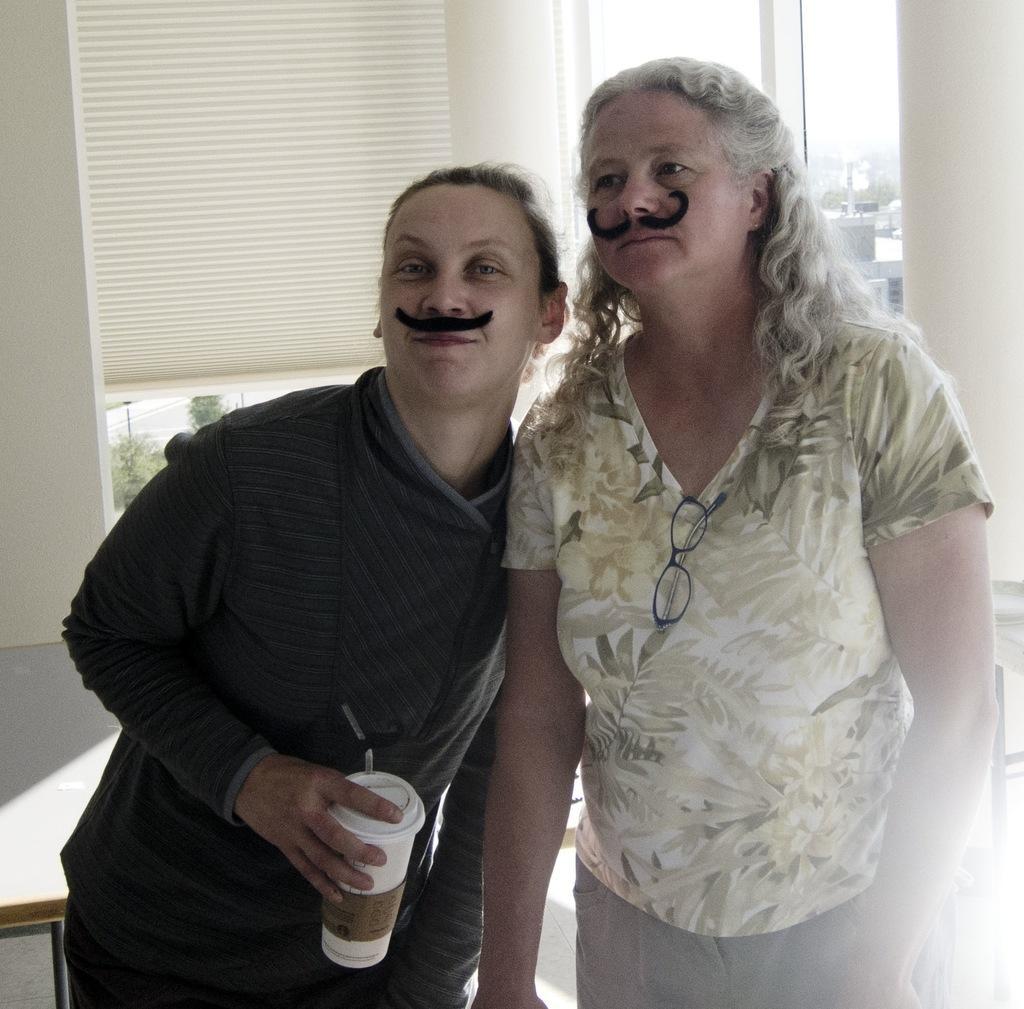Could you give a brief overview of what you see in this image? In this image we can see two women standing. In that a woman is holding a tin with a straw. On the backside we can see a table, window blinds, some trees, buildings and the sky. 